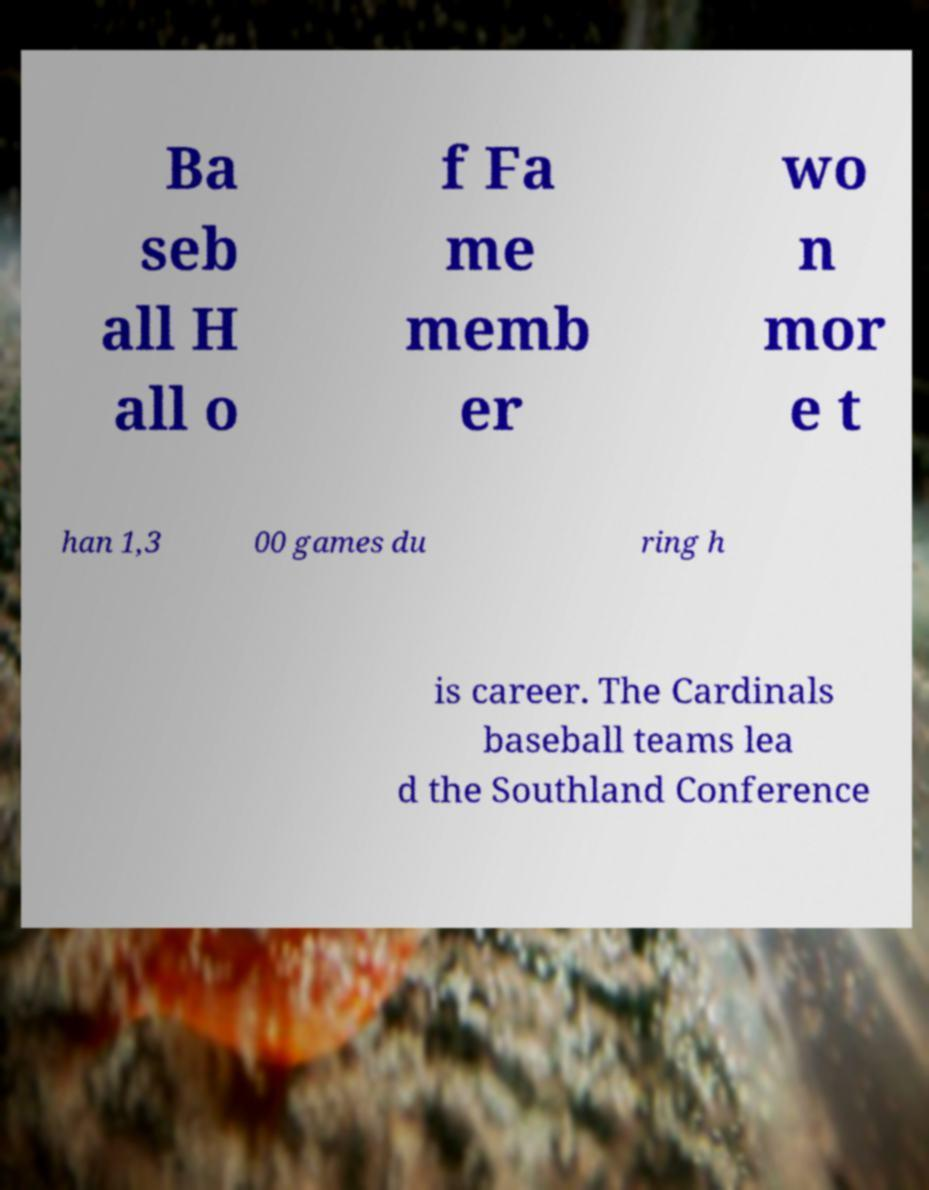I need the written content from this picture converted into text. Can you do that? Ba seb all H all o f Fa me memb er wo n mor e t han 1,3 00 games du ring h is career. The Cardinals baseball teams lea d the Southland Conference 